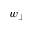<formula> <loc_0><loc_0><loc_500><loc_500>w _ { \perp }</formula> 